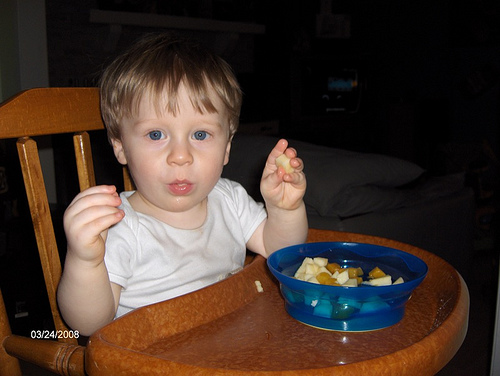<image>
Is the baby to the left of the food? Yes. From this viewpoint, the baby is positioned to the left side relative to the food. 